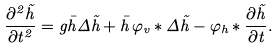<formula> <loc_0><loc_0><loc_500><loc_500>\frac { \partial ^ { 2 } \tilde { h } } { \partial t ^ { 2 } } = g \bar { h } \Delta \tilde { h } + \bar { h } \, \varphi _ { v } * \Delta \tilde { h } - \varphi _ { h } * \frac { \partial \tilde { h } } { \partial t } .</formula> 